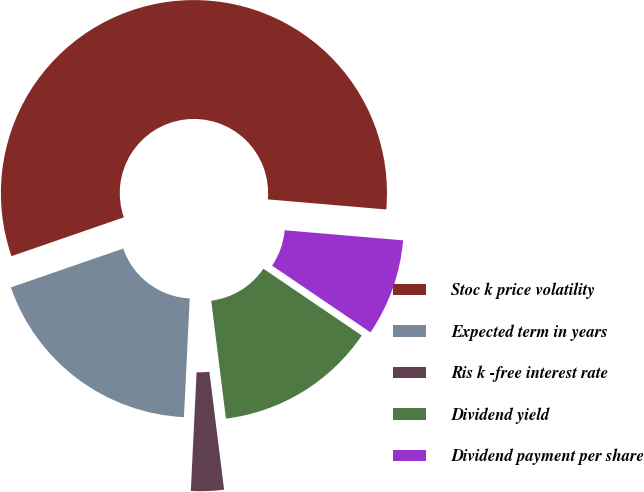Convert chart to OTSL. <chart><loc_0><loc_0><loc_500><loc_500><pie_chart><fcel>Stoc k price volatility<fcel>Expected term in years<fcel>Ris k -free interest rate<fcel>Dividend yield<fcel>Dividend payment per share<nl><fcel>56.64%<fcel>18.93%<fcel>2.75%<fcel>13.53%<fcel>8.14%<nl></chart> 